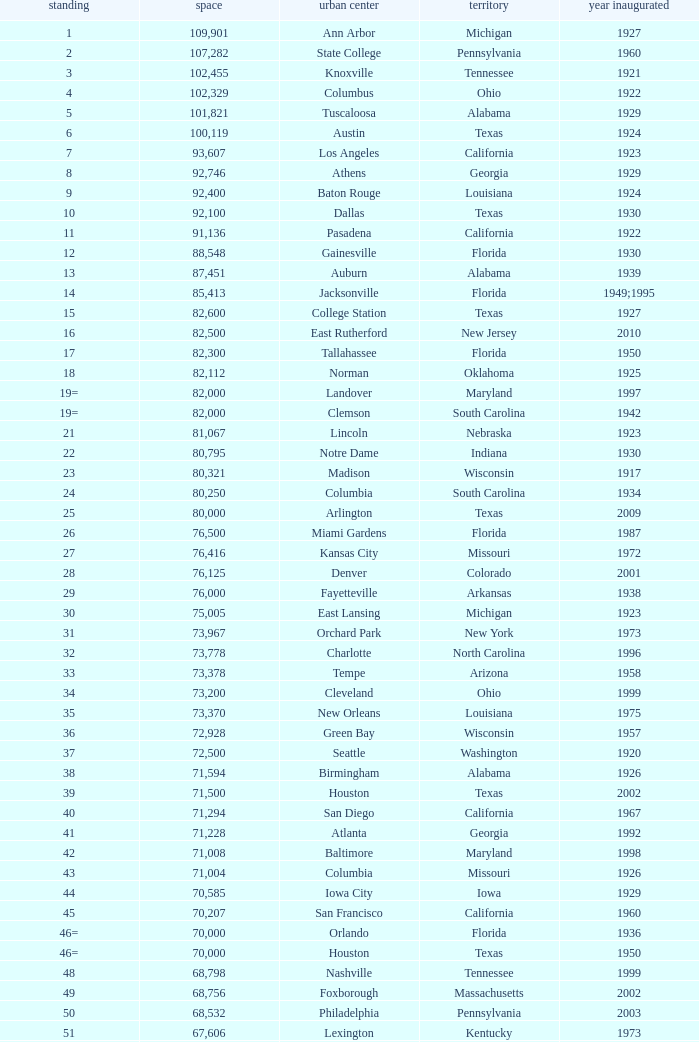What was the year opened for North Carolina with a smaller than 21,500 capacity? 1926.0. 